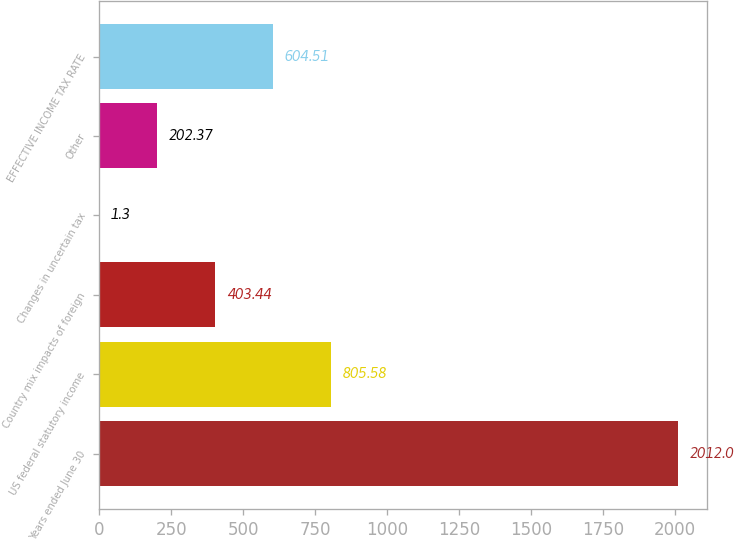Convert chart to OTSL. <chart><loc_0><loc_0><loc_500><loc_500><bar_chart><fcel>Years ended June 30<fcel>US federal statutory income<fcel>Country mix impacts of foreign<fcel>Changes in uncertain tax<fcel>Other<fcel>EFFECTIVE INCOME TAX RATE<nl><fcel>2012<fcel>805.58<fcel>403.44<fcel>1.3<fcel>202.37<fcel>604.51<nl></chart> 